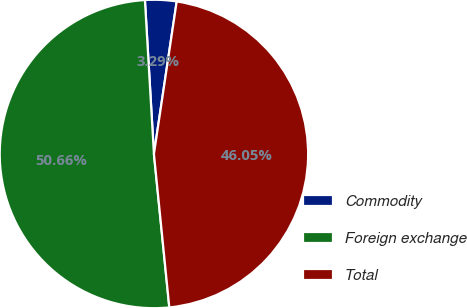Convert chart to OTSL. <chart><loc_0><loc_0><loc_500><loc_500><pie_chart><fcel>Commodity<fcel>Foreign exchange<fcel>Total<nl><fcel>3.29%<fcel>50.66%<fcel>46.05%<nl></chart> 